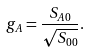Convert formula to latex. <formula><loc_0><loc_0><loc_500><loc_500>g _ { A } = \frac { S _ { A 0 } } { \sqrt { S _ { 0 0 } } } .</formula> 